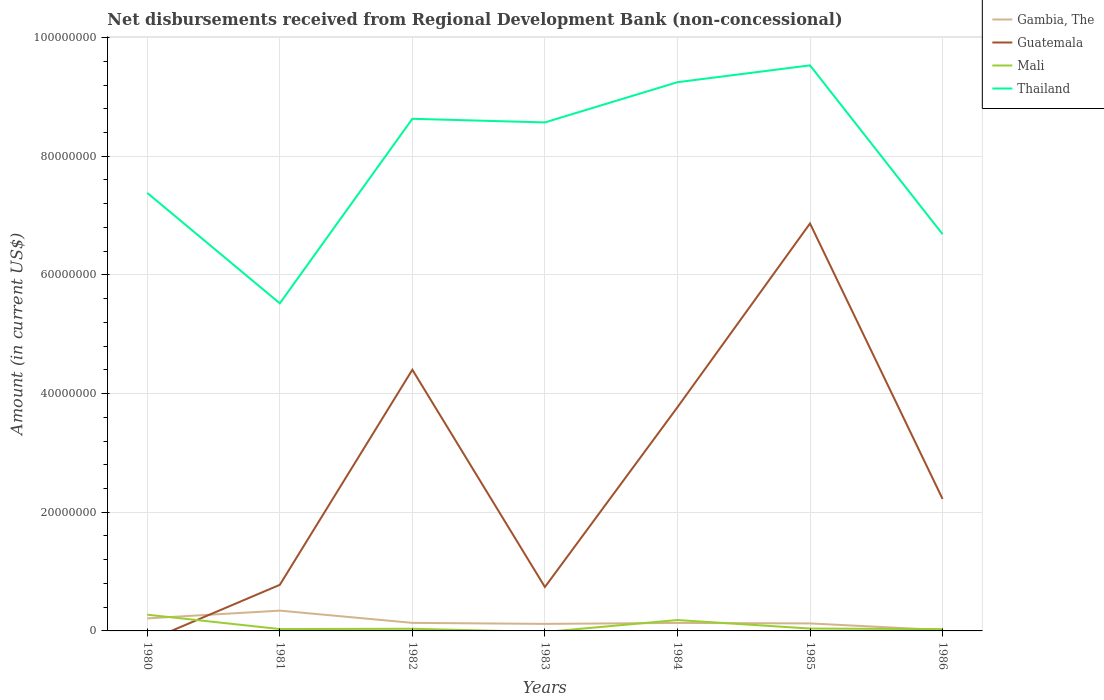Does the line corresponding to Guatemala intersect with the line corresponding to Thailand?
Your answer should be very brief. No. Is the number of lines equal to the number of legend labels?
Ensure brevity in your answer.  No. Across all years, what is the maximum amount of disbursements received from Regional Development Bank in Guatemala?
Ensure brevity in your answer.  0. What is the total amount of disbursements received from Regional Development Bank in Mali in the graph?
Ensure brevity in your answer.  9.70e+04. What is the difference between the highest and the second highest amount of disbursements received from Regional Development Bank in Thailand?
Give a very brief answer. 4.01e+07. Are the values on the major ticks of Y-axis written in scientific E-notation?
Offer a very short reply. No. Where does the legend appear in the graph?
Make the answer very short. Top right. How many legend labels are there?
Keep it short and to the point. 4. How are the legend labels stacked?
Your answer should be very brief. Vertical. What is the title of the graph?
Your answer should be very brief. Net disbursements received from Regional Development Bank (non-concessional). What is the label or title of the Y-axis?
Provide a short and direct response. Amount (in current US$). What is the Amount (in current US$) in Gambia, The in 1980?
Your answer should be very brief. 2.12e+06. What is the Amount (in current US$) of Guatemala in 1980?
Make the answer very short. 0. What is the Amount (in current US$) of Mali in 1980?
Give a very brief answer. 2.74e+06. What is the Amount (in current US$) in Thailand in 1980?
Make the answer very short. 7.38e+07. What is the Amount (in current US$) in Gambia, The in 1981?
Make the answer very short. 3.42e+06. What is the Amount (in current US$) in Guatemala in 1981?
Provide a succinct answer. 7.77e+06. What is the Amount (in current US$) in Mali in 1981?
Provide a short and direct response. 3.14e+05. What is the Amount (in current US$) of Thailand in 1981?
Offer a terse response. 5.52e+07. What is the Amount (in current US$) in Gambia, The in 1982?
Your answer should be very brief. 1.36e+06. What is the Amount (in current US$) of Guatemala in 1982?
Offer a very short reply. 4.40e+07. What is the Amount (in current US$) of Mali in 1982?
Give a very brief answer. 3.64e+05. What is the Amount (in current US$) in Thailand in 1982?
Provide a short and direct response. 8.63e+07. What is the Amount (in current US$) in Gambia, The in 1983?
Your response must be concise. 1.18e+06. What is the Amount (in current US$) of Guatemala in 1983?
Provide a short and direct response. 7.40e+06. What is the Amount (in current US$) in Thailand in 1983?
Make the answer very short. 8.57e+07. What is the Amount (in current US$) of Gambia, The in 1984?
Your answer should be compact. 1.35e+06. What is the Amount (in current US$) of Guatemala in 1984?
Keep it short and to the point. 3.77e+07. What is the Amount (in current US$) of Mali in 1984?
Offer a very short reply. 1.83e+06. What is the Amount (in current US$) in Thailand in 1984?
Offer a very short reply. 9.25e+07. What is the Amount (in current US$) of Gambia, The in 1985?
Your answer should be very brief. 1.26e+06. What is the Amount (in current US$) in Guatemala in 1985?
Your response must be concise. 6.87e+07. What is the Amount (in current US$) in Mali in 1985?
Ensure brevity in your answer.  4.00e+05. What is the Amount (in current US$) of Thailand in 1985?
Your response must be concise. 9.53e+07. What is the Amount (in current US$) of Gambia, The in 1986?
Offer a very short reply. 1.39e+05. What is the Amount (in current US$) of Guatemala in 1986?
Your answer should be very brief. 2.22e+07. What is the Amount (in current US$) of Mali in 1986?
Give a very brief answer. 3.03e+05. What is the Amount (in current US$) of Thailand in 1986?
Provide a succinct answer. 6.69e+07. Across all years, what is the maximum Amount (in current US$) of Gambia, The?
Offer a terse response. 3.42e+06. Across all years, what is the maximum Amount (in current US$) in Guatemala?
Offer a terse response. 6.87e+07. Across all years, what is the maximum Amount (in current US$) in Mali?
Offer a terse response. 2.74e+06. Across all years, what is the maximum Amount (in current US$) of Thailand?
Offer a very short reply. 9.53e+07. Across all years, what is the minimum Amount (in current US$) of Gambia, The?
Your answer should be very brief. 1.39e+05. Across all years, what is the minimum Amount (in current US$) in Guatemala?
Provide a succinct answer. 0. Across all years, what is the minimum Amount (in current US$) of Thailand?
Make the answer very short. 5.52e+07. What is the total Amount (in current US$) in Gambia, The in the graph?
Your answer should be compact. 1.08e+07. What is the total Amount (in current US$) in Guatemala in the graph?
Give a very brief answer. 1.88e+08. What is the total Amount (in current US$) of Mali in the graph?
Keep it short and to the point. 5.95e+06. What is the total Amount (in current US$) of Thailand in the graph?
Give a very brief answer. 5.56e+08. What is the difference between the Amount (in current US$) in Gambia, The in 1980 and that in 1981?
Your response must be concise. -1.30e+06. What is the difference between the Amount (in current US$) in Mali in 1980 and that in 1981?
Provide a short and direct response. 2.42e+06. What is the difference between the Amount (in current US$) of Thailand in 1980 and that in 1981?
Give a very brief answer. 1.86e+07. What is the difference between the Amount (in current US$) in Gambia, The in 1980 and that in 1982?
Provide a succinct answer. 7.58e+05. What is the difference between the Amount (in current US$) in Mali in 1980 and that in 1982?
Keep it short and to the point. 2.37e+06. What is the difference between the Amount (in current US$) in Thailand in 1980 and that in 1982?
Ensure brevity in your answer.  -1.25e+07. What is the difference between the Amount (in current US$) of Gambia, The in 1980 and that in 1983?
Keep it short and to the point. 9.31e+05. What is the difference between the Amount (in current US$) in Thailand in 1980 and that in 1983?
Offer a very short reply. -1.19e+07. What is the difference between the Amount (in current US$) in Gambia, The in 1980 and that in 1984?
Ensure brevity in your answer.  7.68e+05. What is the difference between the Amount (in current US$) of Mali in 1980 and that in 1984?
Offer a terse response. 9.02e+05. What is the difference between the Amount (in current US$) in Thailand in 1980 and that in 1984?
Your response must be concise. -1.87e+07. What is the difference between the Amount (in current US$) in Gambia, The in 1980 and that in 1985?
Give a very brief answer. 8.53e+05. What is the difference between the Amount (in current US$) of Mali in 1980 and that in 1985?
Offer a very short reply. 2.34e+06. What is the difference between the Amount (in current US$) in Thailand in 1980 and that in 1985?
Keep it short and to the point. -2.15e+07. What is the difference between the Amount (in current US$) of Gambia, The in 1980 and that in 1986?
Provide a short and direct response. 1.98e+06. What is the difference between the Amount (in current US$) in Mali in 1980 and that in 1986?
Your answer should be compact. 2.43e+06. What is the difference between the Amount (in current US$) of Thailand in 1980 and that in 1986?
Your answer should be very brief. 6.95e+06. What is the difference between the Amount (in current US$) of Gambia, The in 1981 and that in 1982?
Ensure brevity in your answer.  2.06e+06. What is the difference between the Amount (in current US$) in Guatemala in 1981 and that in 1982?
Give a very brief answer. -3.63e+07. What is the difference between the Amount (in current US$) in Thailand in 1981 and that in 1982?
Provide a succinct answer. -3.11e+07. What is the difference between the Amount (in current US$) in Gambia, The in 1981 and that in 1983?
Offer a very short reply. 2.23e+06. What is the difference between the Amount (in current US$) of Guatemala in 1981 and that in 1983?
Your response must be concise. 3.68e+05. What is the difference between the Amount (in current US$) in Thailand in 1981 and that in 1983?
Your answer should be very brief. -3.05e+07. What is the difference between the Amount (in current US$) in Gambia, The in 1981 and that in 1984?
Your answer should be very brief. 2.07e+06. What is the difference between the Amount (in current US$) of Guatemala in 1981 and that in 1984?
Provide a short and direct response. -2.99e+07. What is the difference between the Amount (in current US$) of Mali in 1981 and that in 1984?
Your answer should be very brief. -1.52e+06. What is the difference between the Amount (in current US$) in Thailand in 1981 and that in 1984?
Give a very brief answer. -3.73e+07. What is the difference between the Amount (in current US$) in Gambia, The in 1981 and that in 1985?
Your answer should be compact. 2.16e+06. What is the difference between the Amount (in current US$) in Guatemala in 1981 and that in 1985?
Your answer should be compact. -6.09e+07. What is the difference between the Amount (in current US$) in Mali in 1981 and that in 1985?
Provide a short and direct response. -8.60e+04. What is the difference between the Amount (in current US$) in Thailand in 1981 and that in 1985?
Your response must be concise. -4.01e+07. What is the difference between the Amount (in current US$) in Gambia, The in 1981 and that in 1986?
Your response must be concise. 3.28e+06. What is the difference between the Amount (in current US$) of Guatemala in 1981 and that in 1986?
Make the answer very short. -1.45e+07. What is the difference between the Amount (in current US$) in Mali in 1981 and that in 1986?
Your answer should be compact. 1.10e+04. What is the difference between the Amount (in current US$) in Thailand in 1981 and that in 1986?
Keep it short and to the point. -1.17e+07. What is the difference between the Amount (in current US$) in Gambia, The in 1982 and that in 1983?
Provide a short and direct response. 1.73e+05. What is the difference between the Amount (in current US$) in Guatemala in 1982 and that in 1983?
Ensure brevity in your answer.  3.66e+07. What is the difference between the Amount (in current US$) in Thailand in 1982 and that in 1983?
Make the answer very short. 6.11e+05. What is the difference between the Amount (in current US$) in Guatemala in 1982 and that in 1984?
Your response must be concise. 6.32e+06. What is the difference between the Amount (in current US$) in Mali in 1982 and that in 1984?
Provide a succinct answer. -1.47e+06. What is the difference between the Amount (in current US$) in Thailand in 1982 and that in 1984?
Make the answer very short. -6.17e+06. What is the difference between the Amount (in current US$) in Gambia, The in 1982 and that in 1985?
Keep it short and to the point. 9.50e+04. What is the difference between the Amount (in current US$) of Guatemala in 1982 and that in 1985?
Offer a terse response. -2.46e+07. What is the difference between the Amount (in current US$) in Mali in 1982 and that in 1985?
Your answer should be compact. -3.60e+04. What is the difference between the Amount (in current US$) in Thailand in 1982 and that in 1985?
Your answer should be very brief. -9.00e+06. What is the difference between the Amount (in current US$) in Gambia, The in 1982 and that in 1986?
Keep it short and to the point. 1.22e+06. What is the difference between the Amount (in current US$) in Guatemala in 1982 and that in 1986?
Keep it short and to the point. 2.18e+07. What is the difference between the Amount (in current US$) in Mali in 1982 and that in 1986?
Ensure brevity in your answer.  6.10e+04. What is the difference between the Amount (in current US$) of Thailand in 1982 and that in 1986?
Your answer should be compact. 1.94e+07. What is the difference between the Amount (in current US$) in Gambia, The in 1983 and that in 1984?
Offer a terse response. -1.63e+05. What is the difference between the Amount (in current US$) of Guatemala in 1983 and that in 1984?
Ensure brevity in your answer.  -3.03e+07. What is the difference between the Amount (in current US$) in Thailand in 1983 and that in 1984?
Offer a very short reply. -6.78e+06. What is the difference between the Amount (in current US$) in Gambia, The in 1983 and that in 1985?
Keep it short and to the point. -7.80e+04. What is the difference between the Amount (in current US$) of Guatemala in 1983 and that in 1985?
Your answer should be very brief. -6.13e+07. What is the difference between the Amount (in current US$) in Thailand in 1983 and that in 1985?
Give a very brief answer. -9.62e+06. What is the difference between the Amount (in current US$) of Gambia, The in 1983 and that in 1986?
Your response must be concise. 1.05e+06. What is the difference between the Amount (in current US$) of Guatemala in 1983 and that in 1986?
Provide a short and direct response. -1.48e+07. What is the difference between the Amount (in current US$) of Thailand in 1983 and that in 1986?
Provide a succinct answer. 1.88e+07. What is the difference between the Amount (in current US$) in Gambia, The in 1984 and that in 1985?
Give a very brief answer. 8.50e+04. What is the difference between the Amount (in current US$) of Guatemala in 1984 and that in 1985?
Keep it short and to the point. -3.10e+07. What is the difference between the Amount (in current US$) of Mali in 1984 and that in 1985?
Provide a succinct answer. 1.43e+06. What is the difference between the Amount (in current US$) in Thailand in 1984 and that in 1985?
Provide a succinct answer. -2.84e+06. What is the difference between the Amount (in current US$) of Gambia, The in 1984 and that in 1986?
Offer a terse response. 1.21e+06. What is the difference between the Amount (in current US$) in Guatemala in 1984 and that in 1986?
Keep it short and to the point. 1.55e+07. What is the difference between the Amount (in current US$) in Mali in 1984 and that in 1986?
Offer a very short reply. 1.53e+06. What is the difference between the Amount (in current US$) of Thailand in 1984 and that in 1986?
Offer a very short reply. 2.56e+07. What is the difference between the Amount (in current US$) of Gambia, The in 1985 and that in 1986?
Keep it short and to the point. 1.12e+06. What is the difference between the Amount (in current US$) in Guatemala in 1985 and that in 1986?
Ensure brevity in your answer.  4.64e+07. What is the difference between the Amount (in current US$) of Mali in 1985 and that in 1986?
Offer a very short reply. 9.70e+04. What is the difference between the Amount (in current US$) in Thailand in 1985 and that in 1986?
Make the answer very short. 2.84e+07. What is the difference between the Amount (in current US$) of Gambia, The in 1980 and the Amount (in current US$) of Guatemala in 1981?
Keep it short and to the point. -5.65e+06. What is the difference between the Amount (in current US$) in Gambia, The in 1980 and the Amount (in current US$) in Mali in 1981?
Offer a very short reply. 1.80e+06. What is the difference between the Amount (in current US$) in Gambia, The in 1980 and the Amount (in current US$) in Thailand in 1981?
Offer a very short reply. -5.31e+07. What is the difference between the Amount (in current US$) of Mali in 1980 and the Amount (in current US$) of Thailand in 1981?
Offer a very short reply. -5.25e+07. What is the difference between the Amount (in current US$) in Gambia, The in 1980 and the Amount (in current US$) in Guatemala in 1982?
Keep it short and to the point. -4.19e+07. What is the difference between the Amount (in current US$) in Gambia, The in 1980 and the Amount (in current US$) in Mali in 1982?
Offer a terse response. 1.75e+06. What is the difference between the Amount (in current US$) in Gambia, The in 1980 and the Amount (in current US$) in Thailand in 1982?
Provide a short and direct response. -8.42e+07. What is the difference between the Amount (in current US$) of Mali in 1980 and the Amount (in current US$) of Thailand in 1982?
Provide a succinct answer. -8.36e+07. What is the difference between the Amount (in current US$) of Gambia, The in 1980 and the Amount (in current US$) of Guatemala in 1983?
Offer a terse response. -5.28e+06. What is the difference between the Amount (in current US$) of Gambia, The in 1980 and the Amount (in current US$) of Thailand in 1983?
Your answer should be compact. -8.36e+07. What is the difference between the Amount (in current US$) in Mali in 1980 and the Amount (in current US$) in Thailand in 1983?
Keep it short and to the point. -8.30e+07. What is the difference between the Amount (in current US$) of Gambia, The in 1980 and the Amount (in current US$) of Guatemala in 1984?
Provide a short and direct response. -3.56e+07. What is the difference between the Amount (in current US$) of Gambia, The in 1980 and the Amount (in current US$) of Mali in 1984?
Provide a succinct answer. 2.83e+05. What is the difference between the Amount (in current US$) of Gambia, The in 1980 and the Amount (in current US$) of Thailand in 1984?
Provide a short and direct response. -9.04e+07. What is the difference between the Amount (in current US$) of Mali in 1980 and the Amount (in current US$) of Thailand in 1984?
Provide a short and direct response. -8.97e+07. What is the difference between the Amount (in current US$) in Gambia, The in 1980 and the Amount (in current US$) in Guatemala in 1985?
Provide a succinct answer. -6.66e+07. What is the difference between the Amount (in current US$) of Gambia, The in 1980 and the Amount (in current US$) of Mali in 1985?
Ensure brevity in your answer.  1.72e+06. What is the difference between the Amount (in current US$) of Gambia, The in 1980 and the Amount (in current US$) of Thailand in 1985?
Offer a very short reply. -9.32e+07. What is the difference between the Amount (in current US$) in Mali in 1980 and the Amount (in current US$) in Thailand in 1985?
Your response must be concise. -9.26e+07. What is the difference between the Amount (in current US$) in Gambia, The in 1980 and the Amount (in current US$) in Guatemala in 1986?
Provide a short and direct response. -2.01e+07. What is the difference between the Amount (in current US$) in Gambia, The in 1980 and the Amount (in current US$) in Mali in 1986?
Make the answer very short. 1.81e+06. What is the difference between the Amount (in current US$) of Gambia, The in 1980 and the Amount (in current US$) of Thailand in 1986?
Give a very brief answer. -6.47e+07. What is the difference between the Amount (in current US$) of Mali in 1980 and the Amount (in current US$) of Thailand in 1986?
Keep it short and to the point. -6.41e+07. What is the difference between the Amount (in current US$) of Gambia, The in 1981 and the Amount (in current US$) of Guatemala in 1982?
Make the answer very short. -4.06e+07. What is the difference between the Amount (in current US$) in Gambia, The in 1981 and the Amount (in current US$) in Mali in 1982?
Your answer should be very brief. 3.06e+06. What is the difference between the Amount (in current US$) of Gambia, The in 1981 and the Amount (in current US$) of Thailand in 1982?
Your answer should be very brief. -8.29e+07. What is the difference between the Amount (in current US$) of Guatemala in 1981 and the Amount (in current US$) of Mali in 1982?
Your response must be concise. 7.40e+06. What is the difference between the Amount (in current US$) of Guatemala in 1981 and the Amount (in current US$) of Thailand in 1982?
Keep it short and to the point. -7.85e+07. What is the difference between the Amount (in current US$) in Mali in 1981 and the Amount (in current US$) in Thailand in 1982?
Provide a short and direct response. -8.60e+07. What is the difference between the Amount (in current US$) of Gambia, The in 1981 and the Amount (in current US$) of Guatemala in 1983?
Provide a short and direct response. -3.98e+06. What is the difference between the Amount (in current US$) in Gambia, The in 1981 and the Amount (in current US$) in Thailand in 1983?
Make the answer very short. -8.23e+07. What is the difference between the Amount (in current US$) of Guatemala in 1981 and the Amount (in current US$) of Thailand in 1983?
Offer a terse response. -7.79e+07. What is the difference between the Amount (in current US$) of Mali in 1981 and the Amount (in current US$) of Thailand in 1983?
Make the answer very short. -8.54e+07. What is the difference between the Amount (in current US$) of Gambia, The in 1981 and the Amount (in current US$) of Guatemala in 1984?
Offer a very short reply. -3.43e+07. What is the difference between the Amount (in current US$) in Gambia, The in 1981 and the Amount (in current US$) in Mali in 1984?
Make the answer very short. 1.59e+06. What is the difference between the Amount (in current US$) in Gambia, The in 1981 and the Amount (in current US$) in Thailand in 1984?
Your answer should be very brief. -8.91e+07. What is the difference between the Amount (in current US$) of Guatemala in 1981 and the Amount (in current US$) of Mali in 1984?
Offer a terse response. 5.93e+06. What is the difference between the Amount (in current US$) in Guatemala in 1981 and the Amount (in current US$) in Thailand in 1984?
Your answer should be compact. -8.47e+07. What is the difference between the Amount (in current US$) in Mali in 1981 and the Amount (in current US$) in Thailand in 1984?
Your response must be concise. -9.22e+07. What is the difference between the Amount (in current US$) in Gambia, The in 1981 and the Amount (in current US$) in Guatemala in 1985?
Your answer should be compact. -6.52e+07. What is the difference between the Amount (in current US$) of Gambia, The in 1981 and the Amount (in current US$) of Mali in 1985?
Your response must be concise. 3.02e+06. What is the difference between the Amount (in current US$) of Gambia, The in 1981 and the Amount (in current US$) of Thailand in 1985?
Give a very brief answer. -9.19e+07. What is the difference between the Amount (in current US$) in Guatemala in 1981 and the Amount (in current US$) in Mali in 1985?
Give a very brief answer. 7.37e+06. What is the difference between the Amount (in current US$) of Guatemala in 1981 and the Amount (in current US$) of Thailand in 1985?
Make the answer very short. -8.75e+07. What is the difference between the Amount (in current US$) of Mali in 1981 and the Amount (in current US$) of Thailand in 1985?
Your answer should be very brief. -9.50e+07. What is the difference between the Amount (in current US$) of Gambia, The in 1981 and the Amount (in current US$) of Guatemala in 1986?
Give a very brief answer. -1.88e+07. What is the difference between the Amount (in current US$) in Gambia, The in 1981 and the Amount (in current US$) in Mali in 1986?
Offer a terse response. 3.12e+06. What is the difference between the Amount (in current US$) in Gambia, The in 1981 and the Amount (in current US$) in Thailand in 1986?
Keep it short and to the point. -6.34e+07. What is the difference between the Amount (in current US$) of Guatemala in 1981 and the Amount (in current US$) of Mali in 1986?
Provide a succinct answer. 7.46e+06. What is the difference between the Amount (in current US$) in Guatemala in 1981 and the Amount (in current US$) in Thailand in 1986?
Give a very brief answer. -5.91e+07. What is the difference between the Amount (in current US$) of Mali in 1981 and the Amount (in current US$) of Thailand in 1986?
Provide a succinct answer. -6.65e+07. What is the difference between the Amount (in current US$) of Gambia, The in 1982 and the Amount (in current US$) of Guatemala in 1983?
Keep it short and to the point. -6.04e+06. What is the difference between the Amount (in current US$) in Gambia, The in 1982 and the Amount (in current US$) in Thailand in 1983?
Give a very brief answer. -8.43e+07. What is the difference between the Amount (in current US$) of Guatemala in 1982 and the Amount (in current US$) of Thailand in 1983?
Give a very brief answer. -4.17e+07. What is the difference between the Amount (in current US$) of Mali in 1982 and the Amount (in current US$) of Thailand in 1983?
Give a very brief answer. -8.53e+07. What is the difference between the Amount (in current US$) of Gambia, The in 1982 and the Amount (in current US$) of Guatemala in 1984?
Provide a short and direct response. -3.63e+07. What is the difference between the Amount (in current US$) of Gambia, The in 1982 and the Amount (in current US$) of Mali in 1984?
Keep it short and to the point. -4.75e+05. What is the difference between the Amount (in current US$) of Gambia, The in 1982 and the Amount (in current US$) of Thailand in 1984?
Offer a very short reply. -9.11e+07. What is the difference between the Amount (in current US$) of Guatemala in 1982 and the Amount (in current US$) of Mali in 1984?
Provide a succinct answer. 4.22e+07. What is the difference between the Amount (in current US$) of Guatemala in 1982 and the Amount (in current US$) of Thailand in 1984?
Keep it short and to the point. -4.85e+07. What is the difference between the Amount (in current US$) in Mali in 1982 and the Amount (in current US$) in Thailand in 1984?
Offer a very short reply. -9.21e+07. What is the difference between the Amount (in current US$) of Gambia, The in 1982 and the Amount (in current US$) of Guatemala in 1985?
Ensure brevity in your answer.  -6.73e+07. What is the difference between the Amount (in current US$) in Gambia, The in 1982 and the Amount (in current US$) in Mali in 1985?
Make the answer very short. 9.58e+05. What is the difference between the Amount (in current US$) of Gambia, The in 1982 and the Amount (in current US$) of Thailand in 1985?
Your answer should be compact. -9.40e+07. What is the difference between the Amount (in current US$) of Guatemala in 1982 and the Amount (in current US$) of Mali in 1985?
Your answer should be compact. 4.36e+07. What is the difference between the Amount (in current US$) in Guatemala in 1982 and the Amount (in current US$) in Thailand in 1985?
Ensure brevity in your answer.  -5.13e+07. What is the difference between the Amount (in current US$) in Mali in 1982 and the Amount (in current US$) in Thailand in 1985?
Your answer should be compact. -9.49e+07. What is the difference between the Amount (in current US$) in Gambia, The in 1982 and the Amount (in current US$) in Guatemala in 1986?
Ensure brevity in your answer.  -2.09e+07. What is the difference between the Amount (in current US$) in Gambia, The in 1982 and the Amount (in current US$) in Mali in 1986?
Provide a short and direct response. 1.06e+06. What is the difference between the Amount (in current US$) of Gambia, The in 1982 and the Amount (in current US$) of Thailand in 1986?
Offer a terse response. -6.55e+07. What is the difference between the Amount (in current US$) in Guatemala in 1982 and the Amount (in current US$) in Mali in 1986?
Ensure brevity in your answer.  4.37e+07. What is the difference between the Amount (in current US$) of Guatemala in 1982 and the Amount (in current US$) of Thailand in 1986?
Provide a succinct answer. -2.28e+07. What is the difference between the Amount (in current US$) of Mali in 1982 and the Amount (in current US$) of Thailand in 1986?
Your answer should be very brief. -6.65e+07. What is the difference between the Amount (in current US$) in Gambia, The in 1983 and the Amount (in current US$) in Guatemala in 1984?
Provide a succinct answer. -3.65e+07. What is the difference between the Amount (in current US$) in Gambia, The in 1983 and the Amount (in current US$) in Mali in 1984?
Ensure brevity in your answer.  -6.48e+05. What is the difference between the Amount (in current US$) in Gambia, The in 1983 and the Amount (in current US$) in Thailand in 1984?
Offer a terse response. -9.13e+07. What is the difference between the Amount (in current US$) of Guatemala in 1983 and the Amount (in current US$) of Mali in 1984?
Offer a very short reply. 5.57e+06. What is the difference between the Amount (in current US$) of Guatemala in 1983 and the Amount (in current US$) of Thailand in 1984?
Keep it short and to the point. -8.51e+07. What is the difference between the Amount (in current US$) of Gambia, The in 1983 and the Amount (in current US$) of Guatemala in 1985?
Keep it short and to the point. -6.75e+07. What is the difference between the Amount (in current US$) in Gambia, The in 1983 and the Amount (in current US$) in Mali in 1985?
Your answer should be very brief. 7.85e+05. What is the difference between the Amount (in current US$) of Gambia, The in 1983 and the Amount (in current US$) of Thailand in 1985?
Give a very brief answer. -9.41e+07. What is the difference between the Amount (in current US$) in Guatemala in 1983 and the Amount (in current US$) in Mali in 1985?
Give a very brief answer. 7.00e+06. What is the difference between the Amount (in current US$) in Guatemala in 1983 and the Amount (in current US$) in Thailand in 1985?
Your response must be concise. -8.79e+07. What is the difference between the Amount (in current US$) in Gambia, The in 1983 and the Amount (in current US$) in Guatemala in 1986?
Provide a short and direct response. -2.11e+07. What is the difference between the Amount (in current US$) of Gambia, The in 1983 and the Amount (in current US$) of Mali in 1986?
Give a very brief answer. 8.82e+05. What is the difference between the Amount (in current US$) in Gambia, The in 1983 and the Amount (in current US$) in Thailand in 1986?
Offer a terse response. -6.57e+07. What is the difference between the Amount (in current US$) of Guatemala in 1983 and the Amount (in current US$) of Mali in 1986?
Your answer should be compact. 7.10e+06. What is the difference between the Amount (in current US$) in Guatemala in 1983 and the Amount (in current US$) in Thailand in 1986?
Your answer should be compact. -5.95e+07. What is the difference between the Amount (in current US$) of Gambia, The in 1984 and the Amount (in current US$) of Guatemala in 1985?
Your answer should be very brief. -6.73e+07. What is the difference between the Amount (in current US$) of Gambia, The in 1984 and the Amount (in current US$) of Mali in 1985?
Offer a very short reply. 9.48e+05. What is the difference between the Amount (in current US$) in Gambia, The in 1984 and the Amount (in current US$) in Thailand in 1985?
Your response must be concise. -9.40e+07. What is the difference between the Amount (in current US$) in Guatemala in 1984 and the Amount (in current US$) in Mali in 1985?
Keep it short and to the point. 3.73e+07. What is the difference between the Amount (in current US$) in Guatemala in 1984 and the Amount (in current US$) in Thailand in 1985?
Keep it short and to the point. -5.76e+07. What is the difference between the Amount (in current US$) of Mali in 1984 and the Amount (in current US$) of Thailand in 1985?
Your response must be concise. -9.35e+07. What is the difference between the Amount (in current US$) in Gambia, The in 1984 and the Amount (in current US$) in Guatemala in 1986?
Offer a very short reply. -2.09e+07. What is the difference between the Amount (in current US$) of Gambia, The in 1984 and the Amount (in current US$) of Mali in 1986?
Give a very brief answer. 1.04e+06. What is the difference between the Amount (in current US$) of Gambia, The in 1984 and the Amount (in current US$) of Thailand in 1986?
Offer a terse response. -6.55e+07. What is the difference between the Amount (in current US$) of Guatemala in 1984 and the Amount (in current US$) of Mali in 1986?
Your answer should be compact. 3.74e+07. What is the difference between the Amount (in current US$) in Guatemala in 1984 and the Amount (in current US$) in Thailand in 1986?
Offer a very short reply. -2.92e+07. What is the difference between the Amount (in current US$) in Mali in 1984 and the Amount (in current US$) in Thailand in 1986?
Make the answer very short. -6.50e+07. What is the difference between the Amount (in current US$) of Gambia, The in 1985 and the Amount (in current US$) of Guatemala in 1986?
Your answer should be compact. -2.10e+07. What is the difference between the Amount (in current US$) in Gambia, The in 1985 and the Amount (in current US$) in Mali in 1986?
Your answer should be very brief. 9.60e+05. What is the difference between the Amount (in current US$) of Gambia, The in 1985 and the Amount (in current US$) of Thailand in 1986?
Make the answer very short. -6.56e+07. What is the difference between the Amount (in current US$) of Guatemala in 1985 and the Amount (in current US$) of Mali in 1986?
Provide a succinct answer. 6.84e+07. What is the difference between the Amount (in current US$) in Guatemala in 1985 and the Amount (in current US$) in Thailand in 1986?
Offer a terse response. 1.80e+06. What is the difference between the Amount (in current US$) in Mali in 1985 and the Amount (in current US$) in Thailand in 1986?
Your response must be concise. -6.65e+07. What is the average Amount (in current US$) of Gambia, The per year?
Offer a terse response. 1.55e+06. What is the average Amount (in current US$) of Guatemala per year?
Offer a very short reply. 2.68e+07. What is the average Amount (in current US$) of Mali per year?
Ensure brevity in your answer.  8.50e+05. What is the average Amount (in current US$) in Thailand per year?
Provide a succinct answer. 7.94e+07. In the year 1980, what is the difference between the Amount (in current US$) in Gambia, The and Amount (in current US$) in Mali?
Your response must be concise. -6.19e+05. In the year 1980, what is the difference between the Amount (in current US$) in Gambia, The and Amount (in current US$) in Thailand?
Ensure brevity in your answer.  -7.17e+07. In the year 1980, what is the difference between the Amount (in current US$) of Mali and Amount (in current US$) of Thailand?
Make the answer very short. -7.11e+07. In the year 1981, what is the difference between the Amount (in current US$) of Gambia, The and Amount (in current US$) of Guatemala?
Your answer should be compact. -4.35e+06. In the year 1981, what is the difference between the Amount (in current US$) of Gambia, The and Amount (in current US$) of Mali?
Provide a short and direct response. 3.10e+06. In the year 1981, what is the difference between the Amount (in current US$) of Gambia, The and Amount (in current US$) of Thailand?
Your answer should be very brief. -5.18e+07. In the year 1981, what is the difference between the Amount (in current US$) in Guatemala and Amount (in current US$) in Mali?
Your response must be concise. 7.45e+06. In the year 1981, what is the difference between the Amount (in current US$) of Guatemala and Amount (in current US$) of Thailand?
Make the answer very short. -4.74e+07. In the year 1981, what is the difference between the Amount (in current US$) of Mali and Amount (in current US$) of Thailand?
Offer a very short reply. -5.49e+07. In the year 1982, what is the difference between the Amount (in current US$) in Gambia, The and Amount (in current US$) in Guatemala?
Your response must be concise. -4.27e+07. In the year 1982, what is the difference between the Amount (in current US$) in Gambia, The and Amount (in current US$) in Mali?
Keep it short and to the point. 9.94e+05. In the year 1982, what is the difference between the Amount (in current US$) of Gambia, The and Amount (in current US$) of Thailand?
Keep it short and to the point. -8.50e+07. In the year 1982, what is the difference between the Amount (in current US$) of Guatemala and Amount (in current US$) of Mali?
Provide a short and direct response. 4.37e+07. In the year 1982, what is the difference between the Amount (in current US$) in Guatemala and Amount (in current US$) in Thailand?
Your answer should be very brief. -4.23e+07. In the year 1982, what is the difference between the Amount (in current US$) in Mali and Amount (in current US$) in Thailand?
Provide a succinct answer. -8.59e+07. In the year 1983, what is the difference between the Amount (in current US$) in Gambia, The and Amount (in current US$) in Guatemala?
Your response must be concise. -6.21e+06. In the year 1983, what is the difference between the Amount (in current US$) in Gambia, The and Amount (in current US$) in Thailand?
Your answer should be very brief. -8.45e+07. In the year 1983, what is the difference between the Amount (in current US$) in Guatemala and Amount (in current US$) in Thailand?
Provide a succinct answer. -7.83e+07. In the year 1984, what is the difference between the Amount (in current US$) in Gambia, The and Amount (in current US$) in Guatemala?
Offer a terse response. -3.64e+07. In the year 1984, what is the difference between the Amount (in current US$) in Gambia, The and Amount (in current US$) in Mali?
Provide a succinct answer. -4.85e+05. In the year 1984, what is the difference between the Amount (in current US$) of Gambia, The and Amount (in current US$) of Thailand?
Your response must be concise. -9.11e+07. In the year 1984, what is the difference between the Amount (in current US$) in Guatemala and Amount (in current US$) in Mali?
Your response must be concise. 3.59e+07. In the year 1984, what is the difference between the Amount (in current US$) in Guatemala and Amount (in current US$) in Thailand?
Provide a short and direct response. -5.48e+07. In the year 1984, what is the difference between the Amount (in current US$) in Mali and Amount (in current US$) in Thailand?
Make the answer very short. -9.06e+07. In the year 1985, what is the difference between the Amount (in current US$) in Gambia, The and Amount (in current US$) in Guatemala?
Make the answer very short. -6.74e+07. In the year 1985, what is the difference between the Amount (in current US$) in Gambia, The and Amount (in current US$) in Mali?
Provide a short and direct response. 8.63e+05. In the year 1985, what is the difference between the Amount (in current US$) in Gambia, The and Amount (in current US$) in Thailand?
Offer a very short reply. -9.40e+07. In the year 1985, what is the difference between the Amount (in current US$) in Guatemala and Amount (in current US$) in Mali?
Your answer should be very brief. 6.83e+07. In the year 1985, what is the difference between the Amount (in current US$) in Guatemala and Amount (in current US$) in Thailand?
Your response must be concise. -2.66e+07. In the year 1985, what is the difference between the Amount (in current US$) in Mali and Amount (in current US$) in Thailand?
Your answer should be compact. -9.49e+07. In the year 1986, what is the difference between the Amount (in current US$) of Gambia, The and Amount (in current US$) of Guatemala?
Provide a short and direct response. -2.21e+07. In the year 1986, what is the difference between the Amount (in current US$) of Gambia, The and Amount (in current US$) of Mali?
Keep it short and to the point. -1.64e+05. In the year 1986, what is the difference between the Amount (in current US$) of Gambia, The and Amount (in current US$) of Thailand?
Give a very brief answer. -6.67e+07. In the year 1986, what is the difference between the Amount (in current US$) of Guatemala and Amount (in current US$) of Mali?
Ensure brevity in your answer.  2.19e+07. In the year 1986, what is the difference between the Amount (in current US$) of Guatemala and Amount (in current US$) of Thailand?
Keep it short and to the point. -4.46e+07. In the year 1986, what is the difference between the Amount (in current US$) in Mali and Amount (in current US$) in Thailand?
Ensure brevity in your answer.  -6.66e+07. What is the ratio of the Amount (in current US$) of Gambia, The in 1980 to that in 1981?
Make the answer very short. 0.62. What is the ratio of the Amount (in current US$) in Mali in 1980 to that in 1981?
Ensure brevity in your answer.  8.71. What is the ratio of the Amount (in current US$) of Thailand in 1980 to that in 1981?
Provide a succinct answer. 1.34. What is the ratio of the Amount (in current US$) in Gambia, The in 1980 to that in 1982?
Keep it short and to the point. 1.56. What is the ratio of the Amount (in current US$) in Mali in 1980 to that in 1982?
Keep it short and to the point. 7.51. What is the ratio of the Amount (in current US$) in Thailand in 1980 to that in 1982?
Your answer should be compact. 0.86. What is the ratio of the Amount (in current US$) in Gambia, The in 1980 to that in 1983?
Ensure brevity in your answer.  1.79. What is the ratio of the Amount (in current US$) of Thailand in 1980 to that in 1983?
Ensure brevity in your answer.  0.86. What is the ratio of the Amount (in current US$) in Gambia, The in 1980 to that in 1984?
Offer a very short reply. 1.57. What is the ratio of the Amount (in current US$) of Mali in 1980 to that in 1984?
Provide a succinct answer. 1.49. What is the ratio of the Amount (in current US$) of Thailand in 1980 to that in 1984?
Provide a short and direct response. 0.8. What is the ratio of the Amount (in current US$) in Gambia, The in 1980 to that in 1985?
Keep it short and to the point. 1.68. What is the ratio of the Amount (in current US$) of Mali in 1980 to that in 1985?
Ensure brevity in your answer.  6.84. What is the ratio of the Amount (in current US$) in Thailand in 1980 to that in 1985?
Your answer should be very brief. 0.77. What is the ratio of the Amount (in current US$) of Gambia, The in 1980 to that in 1986?
Your response must be concise. 15.22. What is the ratio of the Amount (in current US$) in Mali in 1980 to that in 1986?
Offer a very short reply. 9.03. What is the ratio of the Amount (in current US$) of Thailand in 1980 to that in 1986?
Ensure brevity in your answer.  1.1. What is the ratio of the Amount (in current US$) in Gambia, The in 1981 to that in 1982?
Give a very brief answer. 2.52. What is the ratio of the Amount (in current US$) in Guatemala in 1981 to that in 1982?
Offer a very short reply. 0.18. What is the ratio of the Amount (in current US$) in Mali in 1981 to that in 1982?
Provide a short and direct response. 0.86. What is the ratio of the Amount (in current US$) of Thailand in 1981 to that in 1982?
Offer a very short reply. 0.64. What is the ratio of the Amount (in current US$) in Gambia, The in 1981 to that in 1983?
Offer a very short reply. 2.89. What is the ratio of the Amount (in current US$) in Guatemala in 1981 to that in 1983?
Your answer should be compact. 1.05. What is the ratio of the Amount (in current US$) of Thailand in 1981 to that in 1983?
Make the answer very short. 0.64. What is the ratio of the Amount (in current US$) in Gambia, The in 1981 to that in 1984?
Provide a short and direct response. 2.54. What is the ratio of the Amount (in current US$) of Guatemala in 1981 to that in 1984?
Your answer should be very brief. 0.21. What is the ratio of the Amount (in current US$) in Mali in 1981 to that in 1984?
Your answer should be very brief. 0.17. What is the ratio of the Amount (in current US$) of Thailand in 1981 to that in 1984?
Make the answer very short. 0.6. What is the ratio of the Amount (in current US$) in Gambia, The in 1981 to that in 1985?
Your answer should be compact. 2.71. What is the ratio of the Amount (in current US$) of Guatemala in 1981 to that in 1985?
Your answer should be very brief. 0.11. What is the ratio of the Amount (in current US$) of Mali in 1981 to that in 1985?
Ensure brevity in your answer.  0.79. What is the ratio of the Amount (in current US$) in Thailand in 1981 to that in 1985?
Your answer should be compact. 0.58. What is the ratio of the Amount (in current US$) of Gambia, The in 1981 to that in 1986?
Provide a succinct answer. 24.6. What is the ratio of the Amount (in current US$) of Guatemala in 1981 to that in 1986?
Give a very brief answer. 0.35. What is the ratio of the Amount (in current US$) in Mali in 1981 to that in 1986?
Your answer should be compact. 1.04. What is the ratio of the Amount (in current US$) in Thailand in 1981 to that in 1986?
Your answer should be very brief. 0.83. What is the ratio of the Amount (in current US$) in Gambia, The in 1982 to that in 1983?
Your answer should be very brief. 1.15. What is the ratio of the Amount (in current US$) in Guatemala in 1982 to that in 1983?
Ensure brevity in your answer.  5.95. What is the ratio of the Amount (in current US$) of Thailand in 1982 to that in 1983?
Ensure brevity in your answer.  1.01. What is the ratio of the Amount (in current US$) of Gambia, The in 1982 to that in 1984?
Your response must be concise. 1.01. What is the ratio of the Amount (in current US$) in Guatemala in 1982 to that in 1984?
Make the answer very short. 1.17. What is the ratio of the Amount (in current US$) in Mali in 1982 to that in 1984?
Offer a very short reply. 0.2. What is the ratio of the Amount (in current US$) in Thailand in 1982 to that in 1984?
Provide a succinct answer. 0.93. What is the ratio of the Amount (in current US$) in Gambia, The in 1982 to that in 1985?
Provide a succinct answer. 1.08. What is the ratio of the Amount (in current US$) of Guatemala in 1982 to that in 1985?
Your answer should be very brief. 0.64. What is the ratio of the Amount (in current US$) in Mali in 1982 to that in 1985?
Offer a very short reply. 0.91. What is the ratio of the Amount (in current US$) in Thailand in 1982 to that in 1985?
Provide a short and direct response. 0.91. What is the ratio of the Amount (in current US$) in Gambia, The in 1982 to that in 1986?
Make the answer very short. 9.77. What is the ratio of the Amount (in current US$) of Guatemala in 1982 to that in 1986?
Your answer should be very brief. 1.98. What is the ratio of the Amount (in current US$) of Mali in 1982 to that in 1986?
Provide a succinct answer. 1.2. What is the ratio of the Amount (in current US$) of Thailand in 1982 to that in 1986?
Give a very brief answer. 1.29. What is the ratio of the Amount (in current US$) of Gambia, The in 1983 to that in 1984?
Offer a terse response. 0.88. What is the ratio of the Amount (in current US$) in Guatemala in 1983 to that in 1984?
Your answer should be compact. 0.2. What is the ratio of the Amount (in current US$) in Thailand in 1983 to that in 1984?
Make the answer very short. 0.93. What is the ratio of the Amount (in current US$) in Gambia, The in 1983 to that in 1985?
Provide a succinct answer. 0.94. What is the ratio of the Amount (in current US$) of Guatemala in 1983 to that in 1985?
Provide a short and direct response. 0.11. What is the ratio of the Amount (in current US$) in Thailand in 1983 to that in 1985?
Offer a terse response. 0.9. What is the ratio of the Amount (in current US$) of Gambia, The in 1983 to that in 1986?
Offer a very short reply. 8.53. What is the ratio of the Amount (in current US$) in Guatemala in 1983 to that in 1986?
Your response must be concise. 0.33. What is the ratio of the Amount (in current US$) in Thailand in 1983 to that in 1986?
Offer a terse response. 1.28. What is the ratio of the Amount (in current US$) of Gambia, The in 1984 to that in 1985?
Keep it short and to the point. 1.07. What is the ratio of the Amount (in current US$) in Guatemala in 1984 to that in 1985?
Provide a short and direct response. 0.55. What is the ratio of the Amount (in current US$) in Mali in 1984 to that in 1985?
Your answer should be very brief. 4.58. What is the ratio of the Amount (in current US$) in Thailand in 1984 to that in 1985?
Your answer should be compact. 0.97. What is the ratio of the Amount (in current US$) in Gambia, The in 1984 to that in 1986?
Provide a succinct answer. 9.7. What is the ratio of the Amount (in current US$) in Guatemala in 1984 to that in 1986?
Provide a short and direct response. 1.69. What is the ratio of the Amount (in current US$) in Mali in 1984 to that in 1986?
Offer a very short reply. 6.05. What is the ratio of the Amount (in current US$) in Thailand in 1984 to that in 1986?
Provide a short and direct response. 1.38. What is the ratio of the Amount (in current US$) of Gambia, The in 1985 to that in 1986?
Provide a succinct answer. 9.09. What is the ratio of the Amount (in current US$) in Guatemala in 1985 to that in 1986?
Make the answer very short. 3.09. What is the ratio of the Amount (in current US$) of Mali in 1985 to that in 1986?
Keep it short and to the point. 1.32. What is the ratio of the Amount (in current US$) in Thailand in 1985 to that in 1986?
Make the answer very short. 1.43. What is the difference between the highest and the second highest Amount (in current US$) of Gambia, The?
Make the answer very short. 1.30e+06. What is the difference between the highest and the second highest Amount (in current US$) of Guatemala?
Offer a very short reply. 2.46e+07. What is the difference between the highest and the second highest Amount (in current US$) in Mali?
Make the answer very short. 9.02e+05. What is the difference between the highest and the second highest Amount (in current US$) of Thailand?
Keep it short and to the point. 2.84e+06. What is the difference between the highest and the lowest Amount (in current US$) in Gambia, The?
Make the answer very short. 3.28e+06. What is the difference between the highest and the lowest Amount (in current US$) of Guatemala?
Your response must be concise. 6.87e+07. What is the difference between the highest and the lowest Amount (in current US$) of Mali?
Your answer should be very brief. 2.74e+06. What is the difference between the highest and the lowest Amount (in current US$) of Thailand?
Make the answer very short. 4.01e+07. 